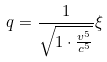<formula> <loc_0><loc_0><loc_500><loc_500>q = \frac { 1 } { \sqrt { 1 \cdot \frac { v ^ { 5 } } { c ^ { 5 } } } } \xi</formula> 